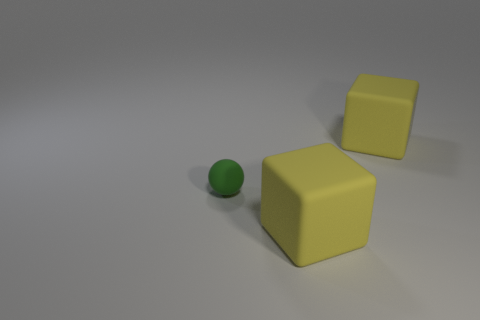What material is the small green object?
Your answer should be very brief. Rubber. Is the color of the large matte object that is behind the tiny matte sphere the same as the big cube that is in front of the sphere?
Offer a terse response. Yes. Is the large cube that is behind the small green sphere made of the same material as the large block in front of the sphere?
Your answer should be compact. Yes. What size is the matte sphere?
Provide a short and direct response. Small. How many rubber blocks are behind the small green matte ball?
Provide a succinct answer. 1. There is a matte block that is on the right side of the large yellow object in front of the small ball; what color is it?
Offer a terse response. Yellow. Are there any other things that have the same shape as the green thing?
Your response must be concise. No. What number of cubes are small green objects or big objects?
Make the answer very short. 2. What number of other things are there of the same material as the tiny object
Provide a short and direct response. 2. The matte thing that is behind the small green matte thing has what shape?
Provide a succinct answer. Cube. 